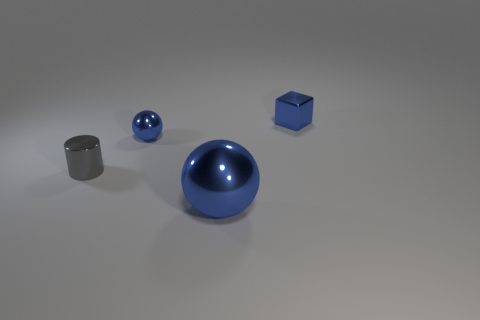How do the textures of the objects compare to each other? The objects have similar smooth and reflective textures, indicating that they might have been rendered using similar materials and finishing processes. The surfaces appear polished, emphasizing the geometric shapes and the uniformity of the set. 